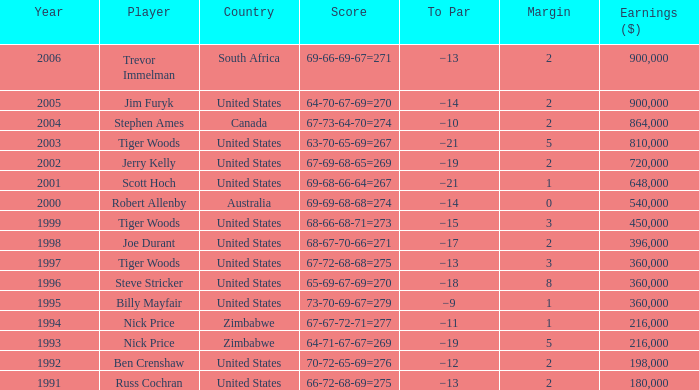Could you parse the entire table as a dict? {'header': ['Year', 'Player', 'Country', 'Score', 'To Par', 'Margin', 'Earnings ($)'], 'rows': [['2006', 'Trevor Immelman', 'South Africa', '69-66-69-67=271', '−13', '2', '900,000'], ['2005', 'Jim Furyk', 'United States', '64-70-67-69=270', '−14', '2', '900,000'], ['2004', 'Stephen Ames', 'Canada', '67-73-64-70=274', '−10', '2', '864,000'], ['2003', 'Tiger Woods', 'United States', '63-70-65-69=267', '−21', '5', '810,000'], ['2002', 'Jerry Kelly', 'United States', '67-69-68-65=269', '−19', '2', '720,000'], ['2001', 'Scott Hoch', 'United States', '69-68-66-64=267', '−21', '1', '648,000'], ['2000', 'Robert Allenby', 'Australia', '69-69-68-68=274', '−14', '0', '540,000'], ['1999', 'Tiger Woods', 'United States', '68-66-68-71=273', '−15', '3', '450,000'], ['1998', 'Joe Durant', 'United States', '68-67-70-66=271', '−17', '2', '396,000'], ['1997', 'Tiger Woods', 'United States', '67-72-68-68=275', '−13', '3', '360,000'], ['1996', 'Steve Stricker', 'United States', '65-69-67-69=270', '−18', '8', '360,000'], ['1995', 'Billy Mayfair', 'United States', '73-70-69-67=279', '−9', '1', '360,000'], ['1994', 'Nick Price', 'Zimbabwe', '67-67-72-71=277', '−11', '1', '216,000'], ['1993', 'Nick Price', 'Zimbabwe', '64-71-67-67=269', '−19', '5', '216,000'], ['1992', 'Ben Crenshaw', 'United States', '70-72-65-69=276', '−12', '2', '198,000'], ['1991', 'Russ Cochran', 'United States', '66-72-68-69=275', '−13', '2', '180,000']]} What is russ cochran's average margin? 2.0. 